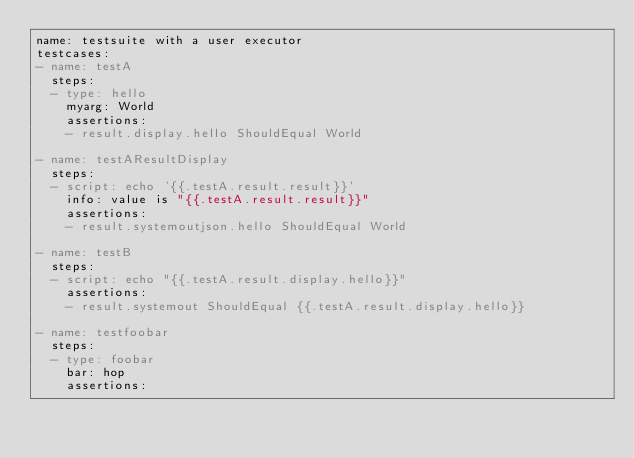<code> <loc_0><loc_0><loc_500><loc_500><_YAML_>name: testsuite with a user executor
testcases:
- name: testA
  steps:
  - type: hello
    myarg: World
    assertions:
    - result.display.hello ShouldEqual World

- name: testAResultDisplay
  steps:
  - script: echo '{{.testA.result.result}}'
    info: value is "{{.testA.result.result}}"
    assertions:
    - result.systemoutjson.hello ShouldEqual World

- name: testB
  steps:
  - script: echo "{{.testA.result.display.hello}}"
    assertions:
    - result.systemout ShouldEqual {{.testA.result.display.hello}}

- name: testfoobar
  steps:
  - type: foobar
    bar: hop
    assertions:</code> 